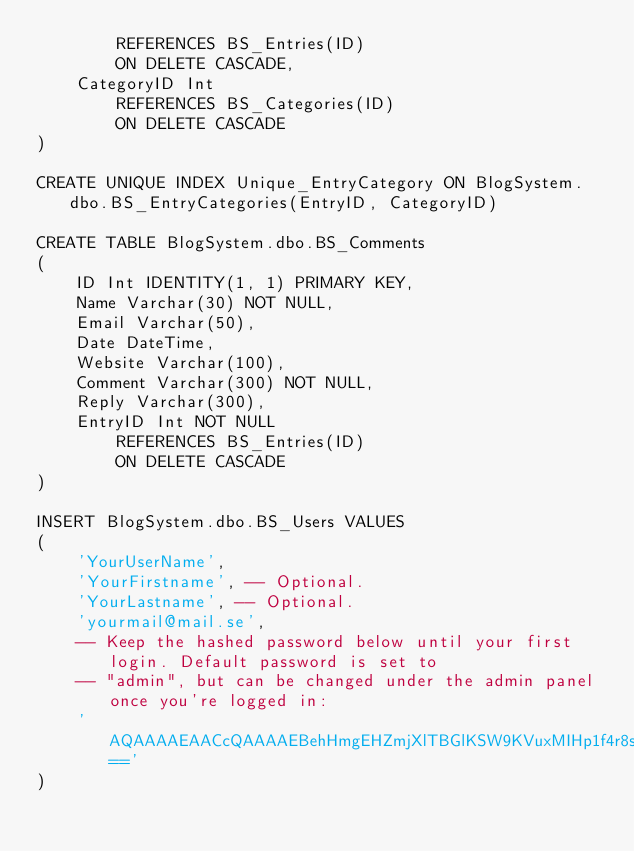Convert code to text. <code><loc_0><loc_0><loc_500><loc_500><_SQL_>		REFERENCES BS_Entries(ID)
		ON DELETE CASCADE,
	CategoryID Int
		REFERENCES BS_Categories(ID)
		ON DELETE CASCADE
)

CREATE UNIQUE INDEX Unique_EntryCategory ON BlogSystem.dbo.BS_EntryCategories(EntryID, CategoryID)

CREATE TABLE BlogSystem.dbo.BS_Comments
(
	ID Int IDENTITY(1, 1) PRIMARY KEY,
	Name Varchar(30) NOT NULL,
	Email Varchar(50),
	Date DateTime,
	Website Varchar(100),
	Comment Varchar(300) NOT NULL,
	Reply Varchar(300),
	EntryID Int NOT NULL
		REFERENCES BS_Entries(ID)
		ON DELETE CASCADE
)

INSERT BlogSystem.dbo.BS_Users VALUES
(
	'YourUserName',
	'YourFirstname', -- Optional.
	'YourLastname', -- Optional.
	'yourmail@mail.se',
	-- Keep the hashed password below until your first login. Default password is set to
	-- "admin", but can be changed under the admin panel once you're logged in:
	'AQAAAAEAACcQAAAAEBehHmgEHZmjXlTBGlKSW9KVuxMIHp1f4r8sC502SFQkGGxiYeef6HFntNMCMdZ76w=='
)</code> 